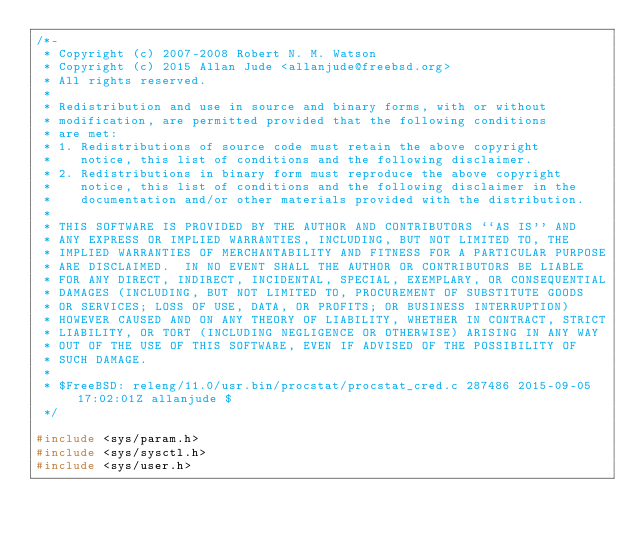<code> <loc_0><loc_0><loc_500><loc_500><_C_>/*-
 * Copyright (c) 2007-2008 Robert N. M. Watson
 * Copyright (c) 2015 Allan Jude <allanjude@freebsd.org>
 * All rights reserved.
 *
 * Redistribution and use in source and binary forms, with or without
 * modification, are permitted provided that the following conditions
 * are met:
 * 1. Redistributions of source code must retain the above copyright
 *    notice, this list of conditions and the following disclaimer.
 * 2. Redistributions in binary form must reproduce the above copyright
 *    notice, this list of conditions and the following disclaimer in the
 *    documentation and/or other materials provided with the distribution.
 *
 * THIS SOFTWARE IS PROVIDED BY THE AUTHOR AND CONTRIBUTORS ``AS IS'' AND
 * ANY EXPRESS OR IMPLIED WARRANTIES, INCLUDING, BUT NOT LIMITED TO, THE
 * IMPLIED WARRANTIES OF MERCHANTABILITY AND FITNESS FOR A PARTICULAR PURPOSE
 * ARE DISCLAIMED.  IN NO EVENT SHALL THE AUTHOR OR CONTRIBUTORS BE LIABLE
 * FOR ANY DIRECT, INDIRECT, INCIDENTAL, SPECIAL, EXEMPLARY, OR CONSEQUENTIAL
 * DAMAGES (INCLUDING, BUT NOT LIMITED TO, PROCUREMENT OF SUBSTITUTE GOODS
 * OR SERVICES; LOSS OF USE, DATA, OR PROFITS; OR BUSINESS INTERRUPTION)
 * HOWEVER CAUSED AND ON ANY THEORY OF LIABILITY, WHETHER IN CONTRACT, STRICT
 * LIABILITY, OR TORT (INCLUDING NEGLIGENCE OR OTHERWISE) ARISING IN ANY WAY
 * OUT OF THE USE OF THIS SOFTWARE, EVEN IF ADVISED OF THE POSSIBILITY OF
 * SUCH DAMAGE.
 *
 * $FreeBSD: releng/11.0/usr.bin/procstat/procstat_cred.c 287486 2015-09-05 17:02:01Z allanjude $
 */

#include <sys/param.h>
#include <sys/sysctl.h>
#include <sys/user.h>
</code> 